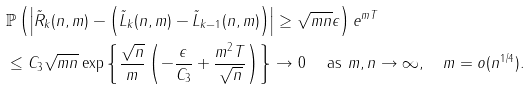Convert formula to latex. <formula><loc_0><loc_0><loc_500><loc_500>& \mathbb { P } \left ( \left | \tilde { R } _ { k } ( n , m ) - \left ( \tilde { L } _ { k } ( n , m ) - \tilde { L } _ { k - 1 } ( n , m ) \right ) \right | \geq \sqrt { m n } \epsilon \right ) e ^ { m T } \\ & \leq C _ { 3 } \sqrt { m n } \exp \left \{ \frac { \sqrt { n } } { m } \left ( - \frac { \epsilon } { C _ { 3 } } + \frac { m ^ { 2 } T } { \sqrt { n } } \right ) \right \} \to 0 \quad \ \text {as } m , n \to \infty , \quad m = o ( n ^ { 1 / 4 } ) .</formula> 